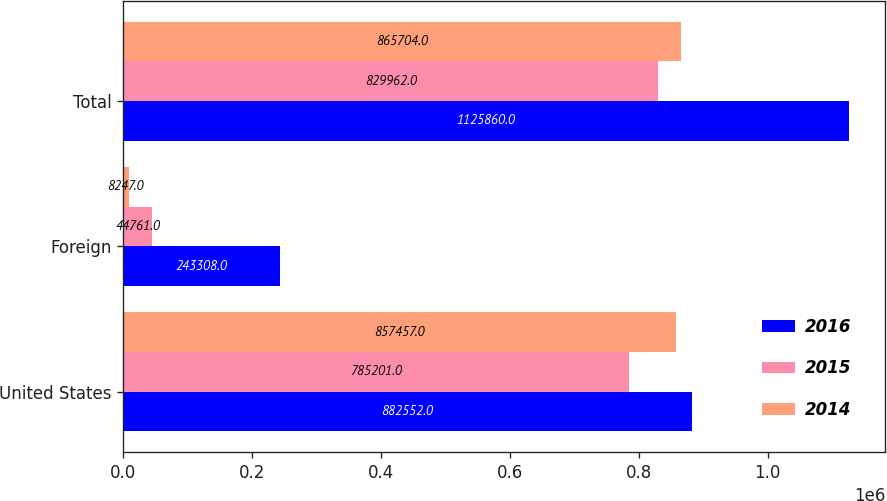<chart> <loc_0><loc_0><loc_500><loc_500><stacked_bar_chart><ecel><fcel>United States<fcel>Foreign<fcel>Total<nl><fcel>2016<fcel>882552<fcel>243308<fcel>1.12586e+06<nl><fcel>2015<fcel>785201<fcel>44761<fcel>829962<nl><fcel>2014<fcel>857457<fcel>8247<fcel>865704<nl></chart> 